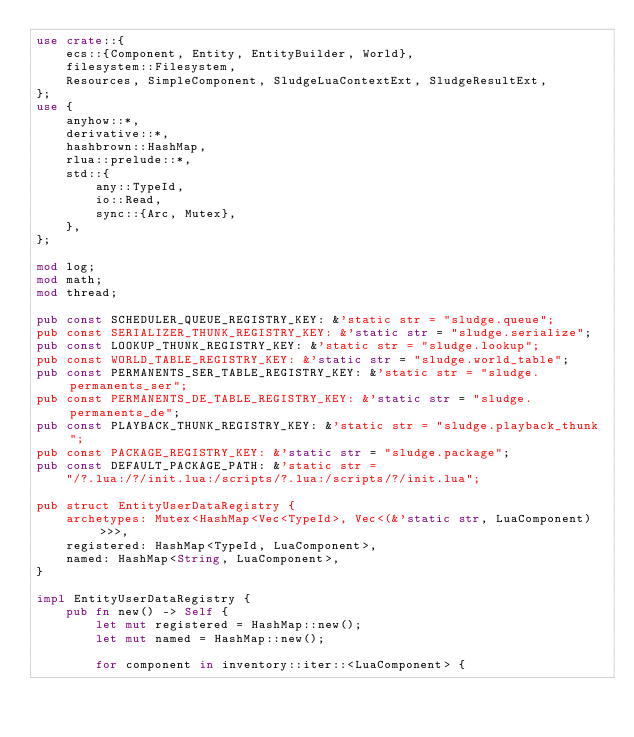<code> <loc_0><loc_0><loc_500><loc_500><_Rust_>use crate::{
    ecs::{Component, Entity, EntityBuilder, World},
    filesystem::Filesystem,
    Resources, SimpleComponent, SludgeLuaContextExt, SludgeResultExt,
};
use {
    anyhow::*,
    derivative::*,
    hashbrown::HashMap,
    rlua::prelude::*,
    std::{
        any::TypeId,
        io::Read,
        sync::{Arc, Mutex},
    },
};

mod log;
mod math;
mod thread;

pub const SCHEDULER_QUEUE_REGISTRY_KEY: &'static str = "sludge.queue";
pub const SERIALIZER_THUNK_REGISTRY_KEY: &'static str = "sludge.serialize";
pub const LOOKUP_THUNK_REGISTRY_KEY: &'static str = "sludge.lookup";
pub const WORLD_TABLE_REGISTRY_KEY: &'static str = "sludge.world_table";
pub const PERMANENTS_SER_TABLE_REGISTRY_KEY: &'static str = "sludge.permanents_ser";
pub const PERMANENTS_DE_TABLE_REGISTRY_KEY: &'static str = "sludge.permanents_de";
pub const PLAYBACK_THUNK_REGISTRY_KEY: &'static str = "sludge.playback_thunk";
pub const PACKAGE_REGISTRY_KEY: &'static str = "sludge.package";
pub const DEFAULT_PACKAGE_PATH: &'static str =
    "/?.lua:/?/init.lua:/scripts/?.lua:/scripts/?/init.lua";

pub struct EntityUserDataRegistry {
    archetypes: Mutex<HashMap<Vec<TypeId>, Vec<(&'static str, LuaComponent)>>>,
    registered: HashMap<TypeId, LuaComponent>,
    named: HashMap<String, LuaComponent>,
}

impl EntityUserDataRegistry {
    pub fn new() -> Self {
        let mut registered = HashMap::new();
        let mut named = HashMap::new();

        for component in inventory::iter::<LuaComponent> {</code> 